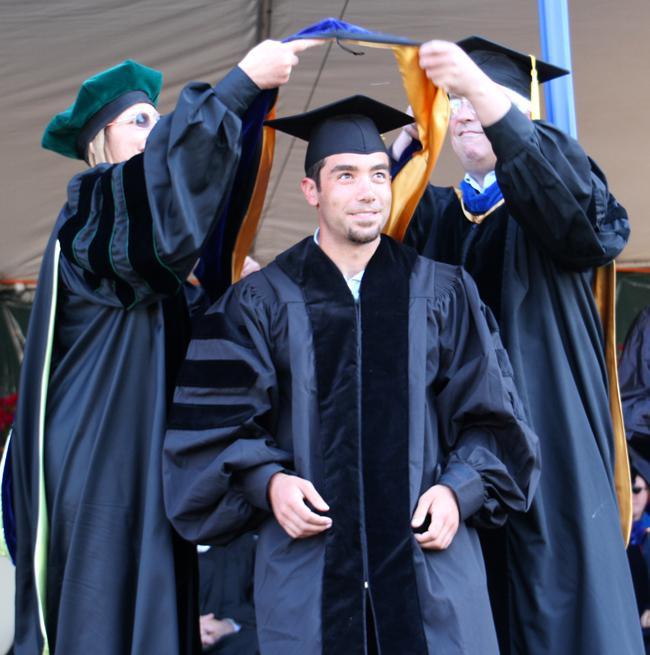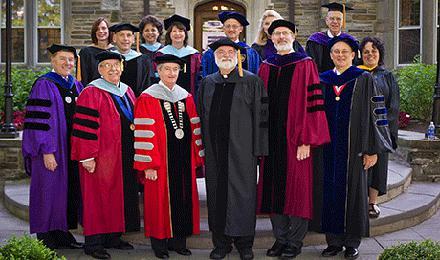The first image is the image on the left, the second image is the image on the right. Examine the images to the left and right. Is the description "There is one guy in the left image, wearing a black robe with blue stripes on the sleeve." accurate? Answer yes or no. No. The first image is the image on the left, the second image is the image on the right. Examine the images to the left and right. Is the description "There is a single male with a blue and grey gown on in one image." accurate? Answer yes or no. No. 